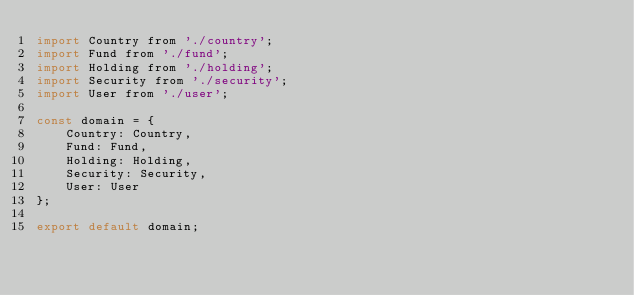<code> <loc_0><loc_0><loc_500><loc_500><_JavaScript_>import Country from './country';
import Fund from './fund';
import Holding from './holding';
import Security from './security';
import User from './user';

const domain = {
    Country: Country,
    Fund: Fund,
    Holding: Holding,
    Security: Security,
    User: User
};

export default domain;
</code> 